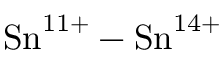<formula> <loc_0><loc_0><loc_500><loc_500>{ S n } ^ { 1 1 + } - { S n } ^ { 1 4 + }</formula> 